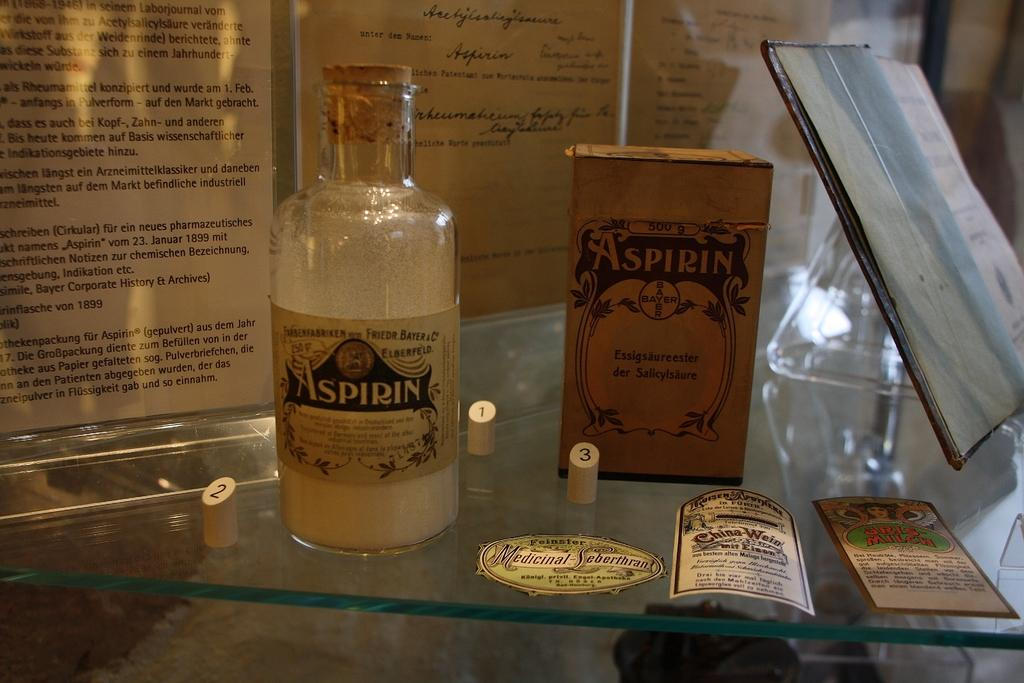Provide a one-sentence caption for the provided image. an old display of an Aspirin bottle and box from Bayer. 